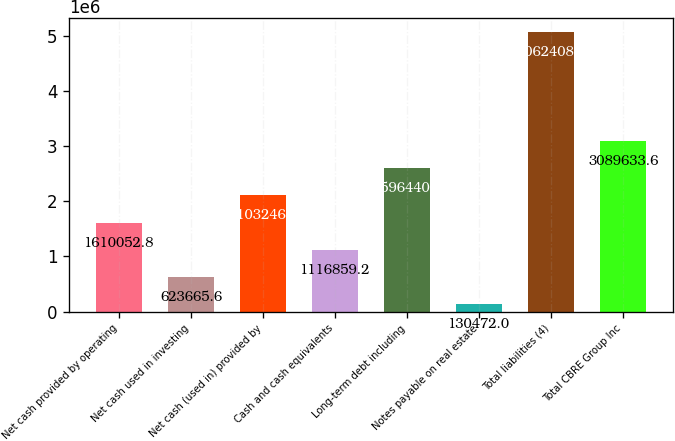Convert chart. <chart><loc_0><loc_0><loc_500><loc_500><bar_chart><fcel>Net cash provided by operating<fcel>Net cash used in investing<fcel>Net cash (used in) provided by<fcel>Cash and cash equivalents<fcel>Long-term debt including<fcel>Notes payable on real estate<fcel>Total liabilities (4)<fcel>Total CBRE Group Inc<nl><fcel>1.61005e+06<fcel>623666<fcel>2.10325e+06<fcel>1.11686e+06<fcel>2.59644e+06<fcel>130472<fcel>5.06241e+06<fcel>3.08963e+06<nl></chart> 